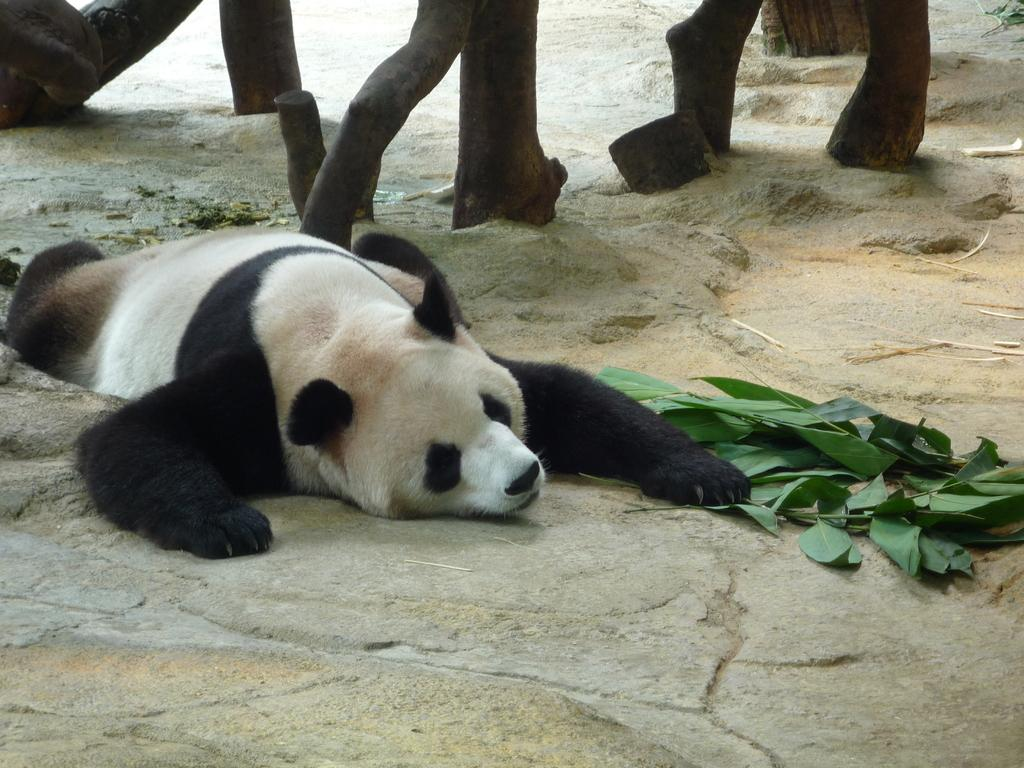What animal is present in the image? There is a panda in the image. What is the panda doing in the image? The panda is laying on the floor. What type of vegetation can be seen in the image? There are leaves in the image. What can be seen in the background of the image? There are wooden logs visible in the background of the image. What type of music is the band playing in the image? There is no band present in the image, so it is not possible to determine what type of music might be played. 